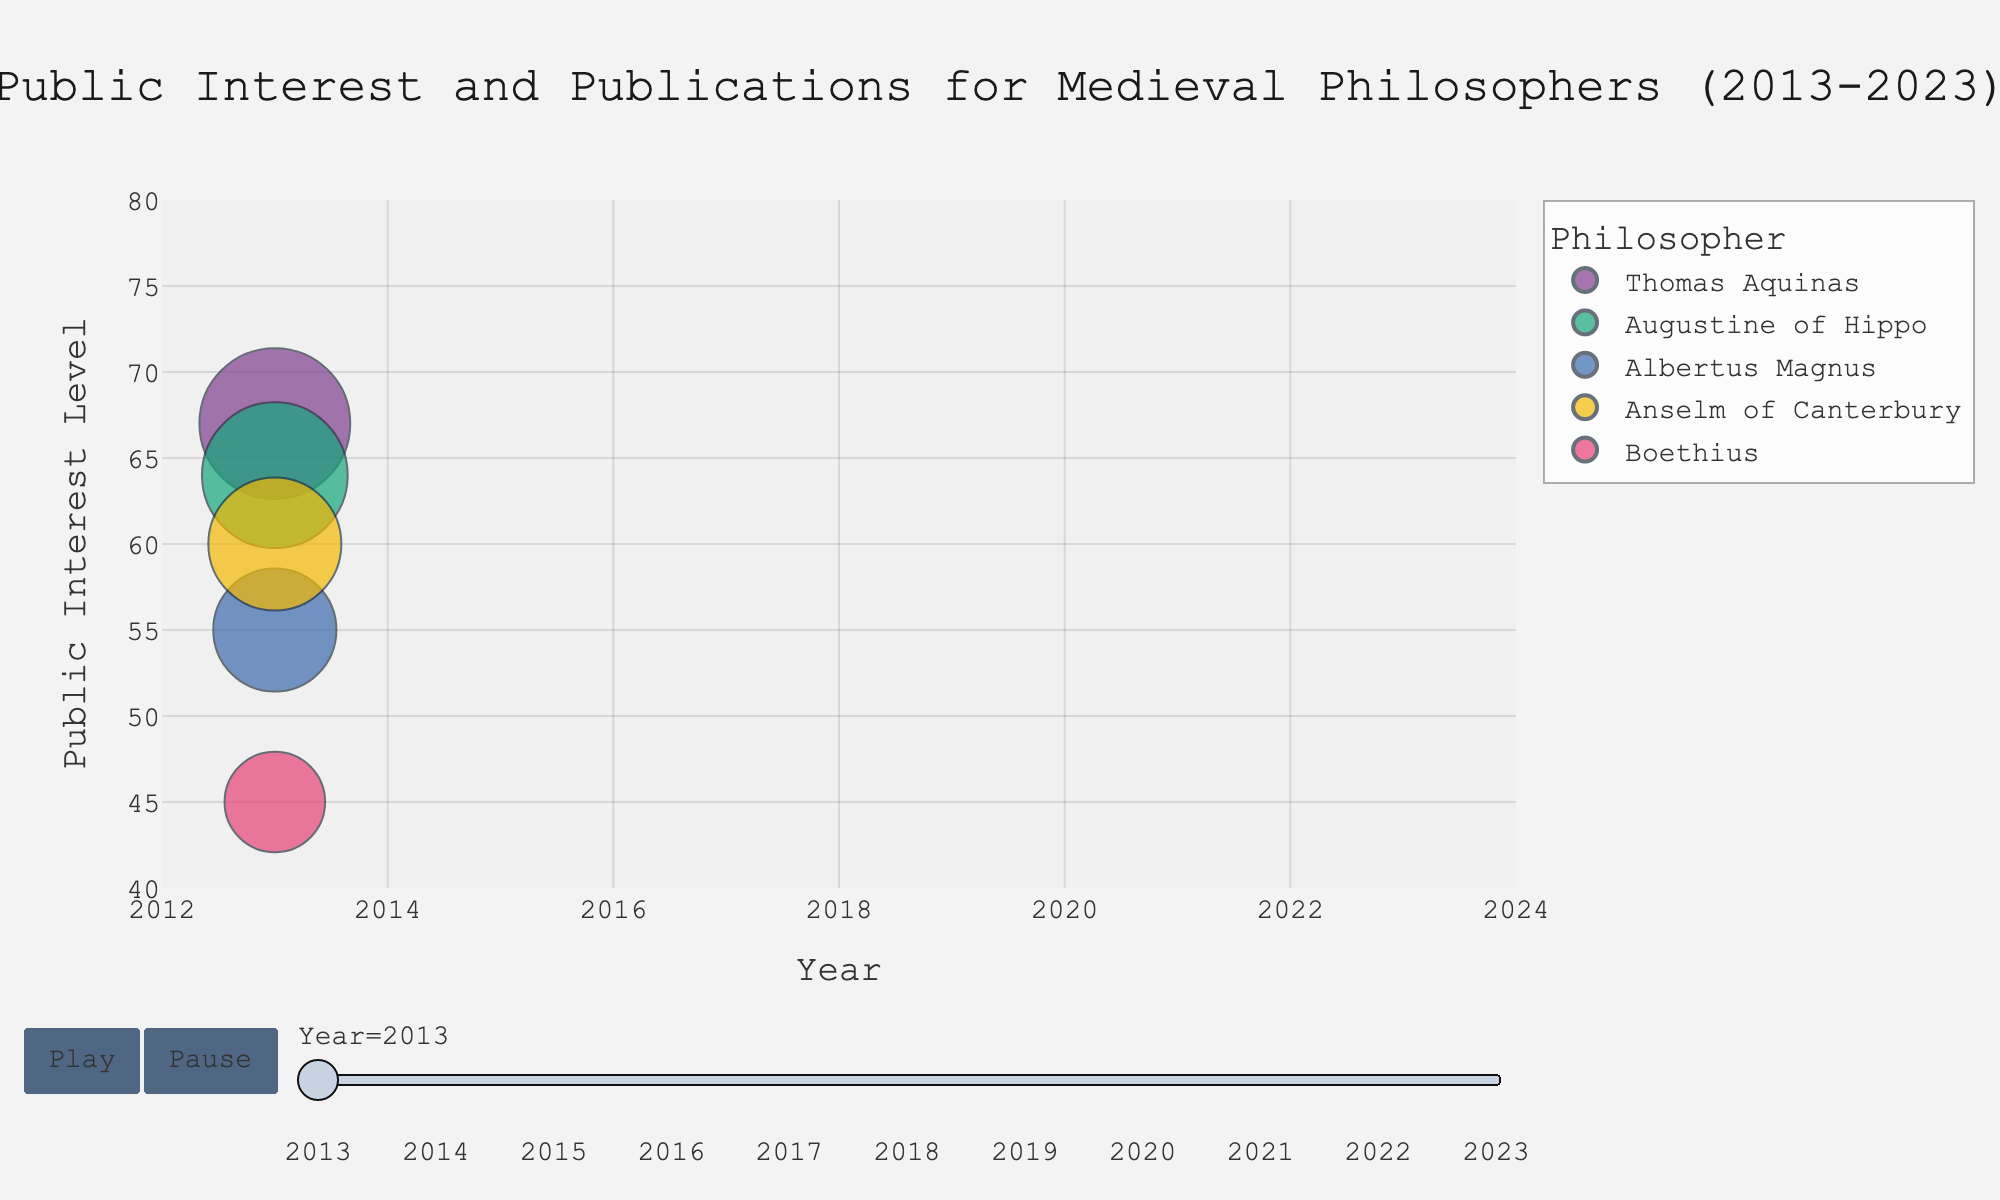What is the title of the bubble chart? The title of a chart is usually found at the top of the figure, typically in a larger font size. **In this chart**, it reads "Public Interest and Publications for Medieval Philosophers (2013-2023)".
Answer: Public Interest and Publications for Medieval Philosophers (2013-2023) Which philosopher had the highest public interest in 2023? To find the answer, look for the bubble representing 2023 that is positioned highest on the vertical axis (Public Interest Level). **In this case**, Thomas Aquinas had the highest public interest with a level of 78.
Answer: Thomas Aquinas How does the public interest level of Boethius in 2013 compare to that in 2023? Compare the vertical positions of the bubbles for Boethius in 2013 and 2023. In 2013, Boethius had a public interest level of 45, whereas in 2023, his interest level is 55. The interest increased by 10 points.
Answer: Boethius had an increase of 10 points Which region is associated with the philosopher Augustine of Hippo based on the chart? Look for the color or bubble representing Augustine of Hippo and check the hover info that shows details. Augustine of Hippo is consistently from Europe throughout the data period.
Answer: Europe What is the trend in the number of publications for Thomas Aquinas from 2014 to 2023? Observe the change in bubble size for Thomas Aquinas over these years. The size correlates with the number of publications. From 2014 to 2023, the publications increased from 46 to 57, indicating a positive trend.
Answer: Increasing trend Which philosopher had the smallest bubble size in 2020, and what does it indicate? The smallest bubble size indicates the lowest publication count. By comparing the bubble sizes in 2020, Boethius had the smallest bubble size, indicating the least number of publications (23) among the philosophers.
Answer: Boethius Between Anselm of Canterbury and Albertus Magnus, who had a higher public interest level in 2018? Compare the vertical positions of Anselm of Canterbury and Albertus Magnus in 2018. Anselm of Canterbury had a public interest level of 67, while Albertus Magnus had a public interest level of 60. Anselm had the higher interest level.
Answer: Anselm of Canterbury Considering all the philosophers, which one showed the most significant increase in public interest level from 2013 to 2023? To determine this, calculate the difference in public interest levels for each philosopher from 2013 to 2023 and compare them. Thomas Aquinas increased from 67 to 78, making the most significant increase (11 points).
Answer: Thomas Aquinas Looking at the overall trend in public interest levels, which philosopher had the most stable interest level from 2013 to 2023? Stability can be judged by observing minimal fluctuations. Albertus Magnus had a relatively stable public interest level, ranging from 55 in 2013 to 65 in 2023 with smaller year-on-year changes compared to others.
Answer: Albertus Magnus 